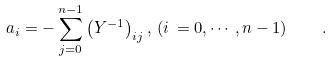<formula> <loc_0><loc_0><loc_500><loc_500>a _ { i } = - \sum _ { j = 0 } ^ { n - 1 } \left ( Y ^ { - 1 } \right ) _ { i j } , \, ( i \, = 0 , \cdots , n - 1 ) \quad .</formula> 